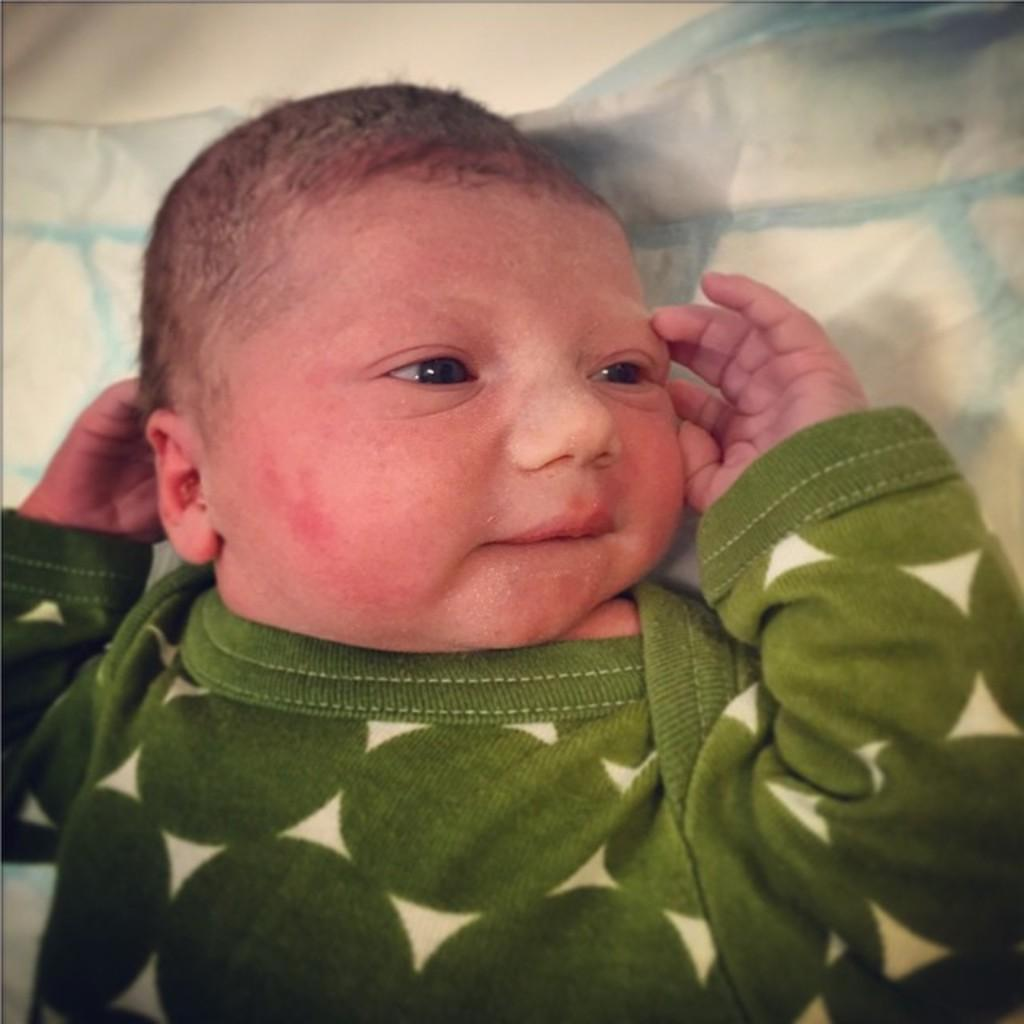What is the main subject of the image? There is a small baby in the image. Where is the baby located in the image? The baby is in the center of the image. What type of crown is the queen wearing in the image? There is no queen present in the image, and therefore no crown can be seen. 